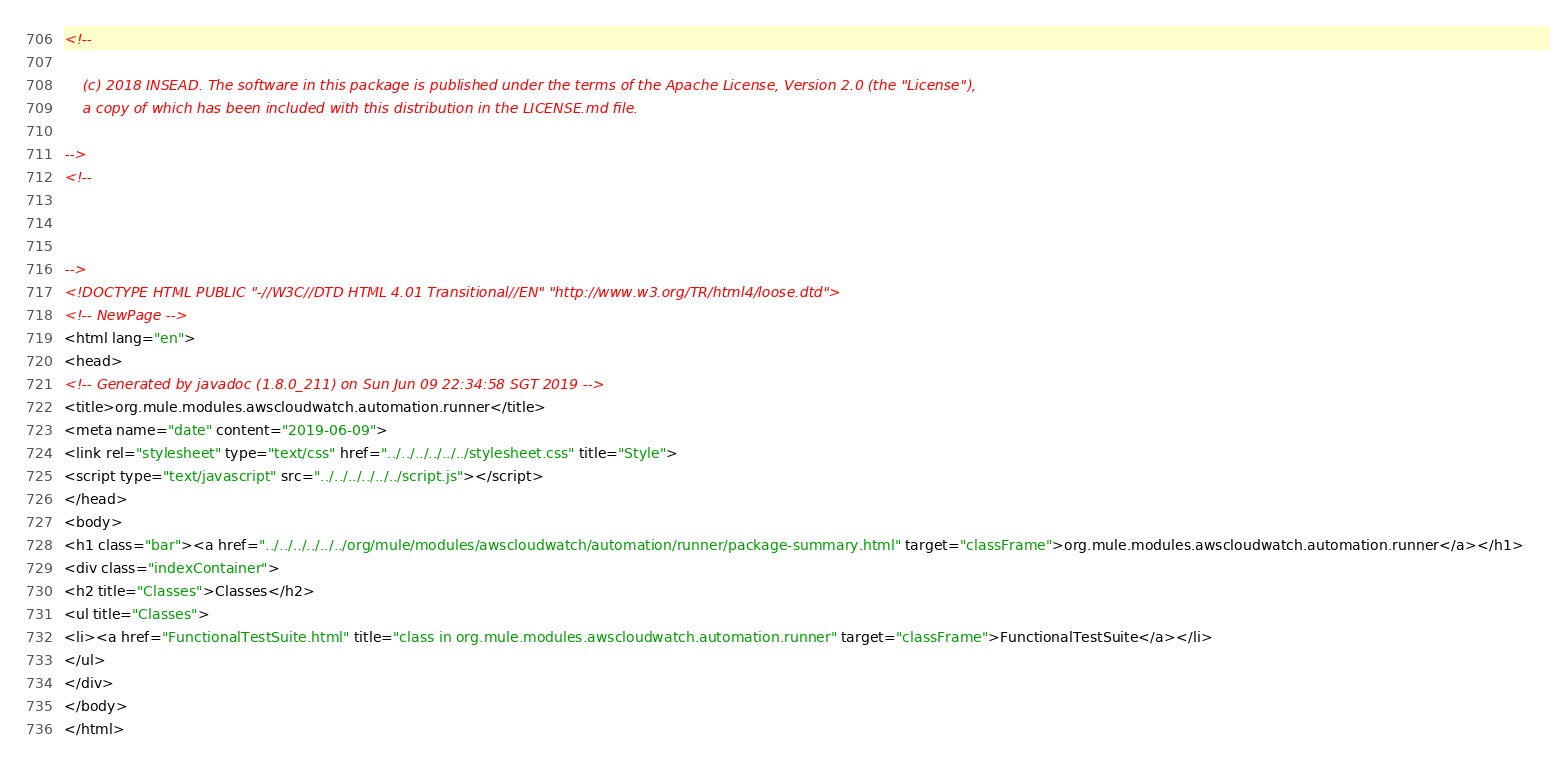<code> <loc_0><loc_0><loc_500><loc_500><_HTML_><!--

    (c) 2018 INSEAD. The software in this package is published under the terms of the Apache License, Version 2.0 (the "License"),
    a copy of which has been included with this distribution in the LICENSE.md file.

-->
<!--



-->
<!DOCTYPE HTML PUBLIC "-//W3C//DTD HTML 4.01 Transitional//EN" "http://www.w3.org/TR/html4/loose.dtd">
<!-- NewPage -->
<html lang="en">
<head>
<!-- Generated by javadoc (1.8.0_211) on Sun Jun 09 22:34:58 SGT 2019 -->
<title>org.mule.modules.awscloudwatch.automation.runner</title>
<meta name="date" content="2019-06-09">
<link rel="stylesheet" type="text/css" href="../../../../../../stylesheet.css" title="Style">
<script type="text/javascript" src="../../../../../../script.js"></script>
</head>
<body>
<h1 class="bar"><a href="../../../../../../org/mule/modules/awscloudwatch/automation/runner/package-summary.html" target="classFrame">org.mule.modules.awscloudwatch.automation.runner</a></h1>
<div class="indexContainer">
<h2 title="Classes">Classes</h2>
<ul title="Classes">
<li><a href="FunctionalTestSuite.html" title="class in org.mule.modules.awscloudwatch.automation.runner" target="classFrame">FunctionalTestSuite</a></li>
</ul>
</div>
</body>
</html>
</code> 